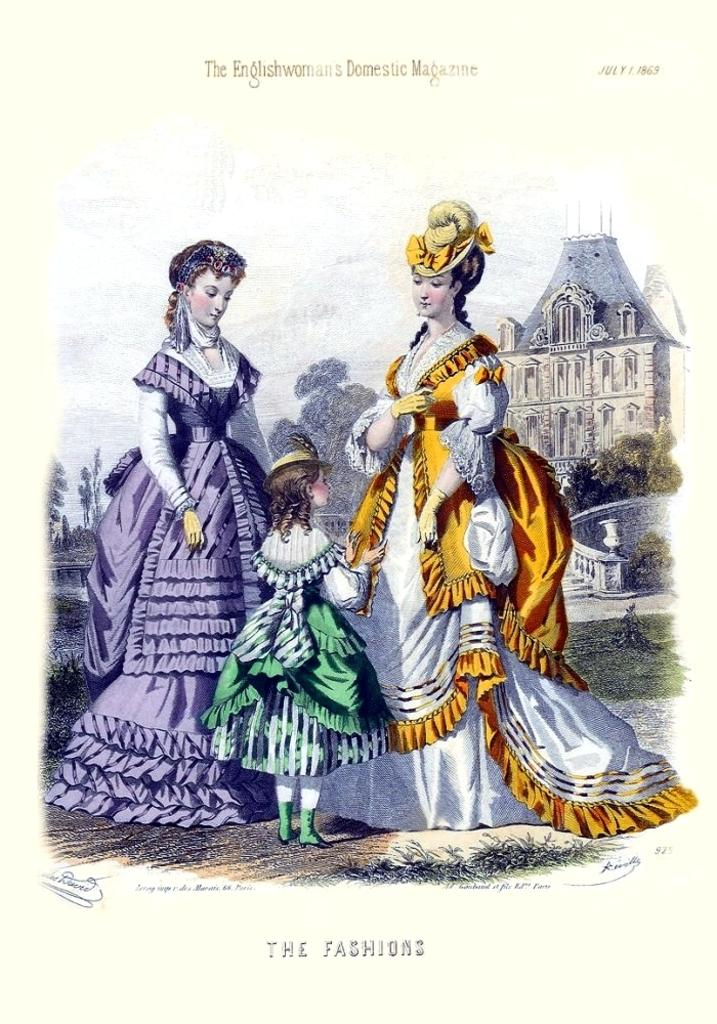What is featured on the poster in the image? There is a poster in the image that contains images of people, a building, stairs, and the ground. Can you describe the images of people on the poster? The images of people on the poster are not specified, but they are part of the overall design. What type of structure is depicted on the poster? The poster shows a building. Are there any architectural features depicted on the poster? Yes, the poster shows stairs. What else can be seen on the poster besides images and text? The ground is visible on the poster. What type of bell can be heard ringing in the image? There is no bell present in the image, and therefore no sound can be heard. 